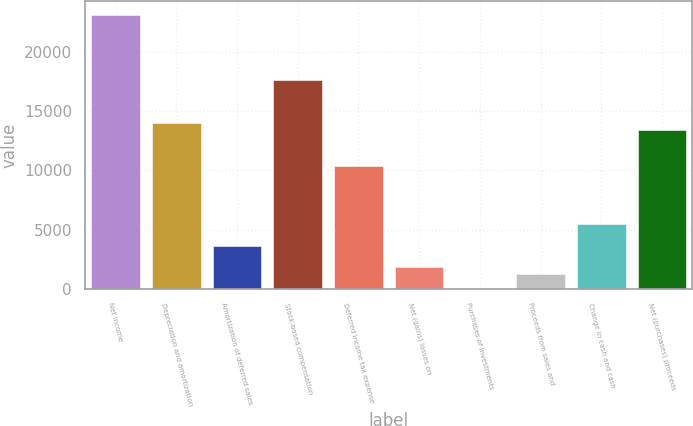Convert chart to OTSL. <chart><loc_0><loc_0><loc_500><loc_500><bar_chart><fcel>Net income<fcel>Depreciation and amortization<fcel>Amortization of deferred sales<fcel>Stock-based compensation<fcel>Deferred income tax expense<fcel>Net (gains) losses on<fcel>Purchases of investments<fcel>Proceeds from sales and<fcel>Change in cash and cash<fcel>Net (purchases) proceeds<nl><fcel>23112.6<fcel>13989.6<fcel>3650.2<fcel>17638.8<fcel>10340.4<fcel>1825.6<fcel>1<fcel>1217.4<fcel>5474.8<fcel>13381.4<nl></chart> 